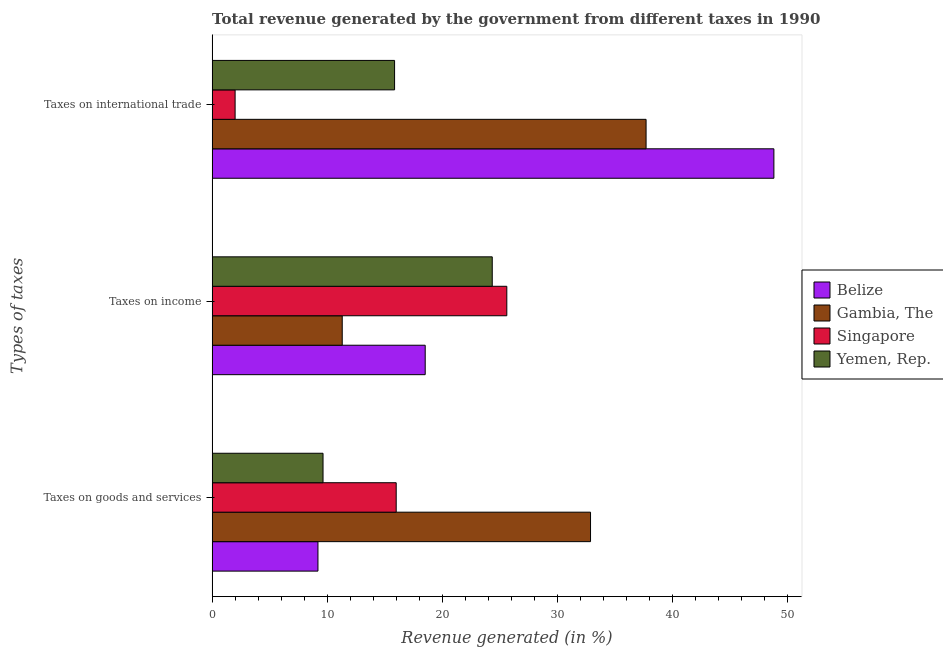How many groups of bars are there?
Provide a succinct answer. 3. Are the number of bars on each tick of the Y-axis equal?
Keep it short and to the point. Yes. What is the label of the 3rd group of bars from the top?
Your response must be concise. Taxes on goods and services. What is the percentage of revenue generated by taxes on income in Singapore?
Make the answer very short. 25.61. Across all countries, what is the maximum percentage of revenue generated by taxes on goods and services?
Your answer should be compact. 32.89. Across all countries, what is the minimum percentage of revenue generated by taxes on income?
Give a very brief answer. 11.31. In which country was the percentage of revenue generated by tax on international trade maximum?
Make the answer very short. Belize. In which country was the percentage of revenue generated by tax on international trade minimum?
Give a very brief answer. Singapore. What is the total percentage of revenue generated by tax on international trade in the graph?
Your answer should be compact. 104.39. What is the difference between the percentage of revenue generated by tax on international trade in Yemen, Rep. and that in Belize?
Keep it short and to the point. -32.97. What is the difference between the percentage of revenue generated by tax on international trade in Singapore and the percentage of revenue generated by taxes on income in Gambia, The?
Provide a short and direct response. -9.31. What is the average percentage of revenue generated by taxes on goods and services per country?
Offer a terse response. 16.93. What is the difference between the percentage of revenue generated by tax on international trade and percentage of revenue generated by taxes on goods and services in Yemen, Rep.?
Make the answer very short. 6.22. In how many countries, is the percentage of revenue generated by tax on international trade greater than 48 %?
Your response must be concise. 1. What is the ratio of the percentage of revenue generated by tax on international trade in Singapore to that in Gambia, The?
Provide a succinct answer. 0.05. Is the percentage of revenue generated by tax on international trade in Yemen, Rep. less than that in Belize?
Keep it short and to the point. Yes. What is the difference between the highest and the second highest percentage of revenue generated by taxes on income?
Make the answer very short. 1.26. What is the difference between the highest and the lowest percentage of revenue generated by taxes on income?
Keep it short and to the point. 14.3. In how many countries, is the percentage of revenue generated by tax on international trade greater than the average percentage of revenue generated by tax on international trade taken over all countries?
Provide a short and direct response. 2. What does the 2nd bar from the top in Taxes on income represents?
Make the answer very short. Singapore. What does the 2nd bar from the bottom in Taxes on goods and services represents?
Make the answer very short. Gambia, The. Is it the case that in every country, the sum of the percentage of revenue generated by taxes on goods and services and percentage of revenue generated by taxes on income is greater than the percentage of revenue generated by tax on international trade?
Ensure brevity in your answer.  No. Are all the bars in the graph horizontal?
Make the answer very short. Yes. What is the difference between two consecutive major ticks on the X-axis?
Offer a terse response. 10. Are the values on the major ticks of X-axis written in scientific E-notation?
Offer a terse response. No. Does the graph contain grids?
Make the answer very short. No. How many legend labels are there?
Offer a terse response. 4. What is the title of the graph?
Make the answer very short. Total revenue generated by the government from different taxes in 1990. Does "Benin" appear as one of the legend labels in the graph?
Keep it short and to the point. No. What is the label or title of the X-axis?
Give a very brief answer. Revenue generated (in %). What is the label or title of the Y-axis?
Provide a short and direct response. Types of taxes. What is the Revenue generated (in %) in Belize in Taxes on goods and services?
Ensure brevity in your answer.  9.2. What is the Revenue generated (in %) of Gambia, The in Taxes on goods and services?
Provide a succinct answer. 32.89. What is the Revenue generated (in %) in Singapore in Taxes on goods and services?
Keep it short and to the point. 16. What is the Revenue generated (in %) in Yemen, Rep. in Taxes on goods and services?
Your response must be concise. 9.64. What is the Revenue generated (in %) of Belize in Taxes on income?
Offer a terse response. 18.52. What is the Revenue generated (in %) in Gambia, The in Taxes on income?
Offer a terse response. 11.31. What is the Revenue generated (in %) in Singapore in Taxes on income?
Your answer should be compact. 25.61. What is the Revenue generated (in %) in Yemen, Rep. in Taxes on income?
Provide a succinct answer. 24.34. What is the Revenue generated (in %) of Belize in Taxes on international trade?
Provide a succinct answer. 48.82. What is the Revenue generated (in %) in Gambia, The in Taxes on international trade?
Offer a very short reply. 37.71. What is the Revenue generated (in %) in Singapore in Taxes on international trade?
Your response must be concise. 2. What is the Revenue generated (in %) in Yemen, Rep. in Taxes on international trade?
Provide a short and direct response. 15.86. Across all Types of taxes, what is the maximum Revenue generated (in %) in Belize?
Keep it short and to the point. 48.82. Across all Types of taxes, what is the maximum Revenue generated (in %) of Gambia, The?
Keep it short and to the point. 37.71. Across all Types of taxes, what is the maximum Revenue generated (in %) in Singapore?
Provide a succinct answer. 25.61. Across all Types of taxes, what is the maximum Revenue generated (in %) of Yemen, Rep.?
Give a very brief answer. 24.34. Across all Types of taxes, what is the minimum Revenue generated (in %) of Belize?
Offer a terse response. 9.2. Across all Types of taxes, what is the minimum Revenue generated (in %) of Gambia, The?
Keep it short and to the point. 11.31. Across all Types of taxes, what is the minimum Revenue generated (in %) of Singapore?
Give a very brief answer. 2. Across all Types of taxes, what is the minimum Revenue generated (in %) of Yemen, Rep.?
Make the answer very short. 9.64. What is the total Revenue generated (in %) of Belize in the graph?
Give a very brief answer. 76.54. What is the total Revenue generated (in %) of Gambia, The in the graph?
Your response must be concise. 81.91. What is the total Revenue generated (in %) in Singapore in the graph?
Keep it short and to the point. 43.6. What is the total Revenue generated (in %) in Yemen, Rep. in the graph?
Ensure brevity in your answer.  49.84. What is the difference between the Revenue generated (in %) in Belize in Taxes on goods and services and that in Taxes on income?
Your answer should be compact. -9.32. What is the difference between the Revenue generated (in %) in Gambia, The in Taxes on goods and services and that in Taxes on income?
Offer a very short reply. 21.58. What is the difference between the Revenue generated (in %) in Singapore in Taxes on goods and services and that in Taxes on income?
Provide a short and direct response. -9.61. What is the difference between the Revenue generated (in %) of Yemen, Rep. in Taxes on goods and services and that in Taxes on income?
Ensure brevity in your answer.  -14.71. What is the difference between the Revenue generated (in %) of Belize in Taxes on goods and services and that in Taxes on international trade?
Your answer should be compact. -39.62. What is the difference between the Revenue generated (in %) of Gambia, The in Taxes on goods and services and that in Taxes on international trade?
Offer a very short reply. -4.83. What is the difference between the Revenue generated (in %) of Singapore in Taxes on goods and services and that in Taxes on international trade?
Keep it short and to the point. 14. What is the difference between the Revenue generated (in %) in Yemen, Rep. in Taxes on goods and services and that in Taxes on international trade?
Give a very brief answer. -6.22. What is the difference between the Revenue generated (in %) of Belize in Taxes on income and that in Taxes on international trade?
Make the answer very short. -30.3. What is the difference between the Revenue generated (in %) of Gambia, The in Taxes on income and that in Taxes on international trade?
Your response must be concise. -26.41. What is the difference between the Revenue generated (in %) in Singapore in Taxes on income and that in Taxes on international trade?
Provide a succinct answer. 23.61. What is the difference between the Revenue generated (in %) in Yemen, Rep. in Taxes on income and that in Taxes on international trade?
Your response must be concise. 8.49. What is the difference between the Revenue generated (in %) in Belize in Taxes on goods and services and the Revenue generated (in %) in Gambia, The in Taxes on income?
Provide a short and direct response. -2.11. What is the difference between the Revenue generated (in %) in Belize in Taxes on goods and services and the Revenue generated (in %) in Singapore in Taxes on income?
Ensure brevity in your answer.  -16.41. What is the difference between the Revenue generated (in %) in Belize in Taxes on goods and services and the Revenue generated (in %) in Yemen, Rep. in Taxes on income?
Ensure brevity in your answer.  -15.15. What is the difference between the Revenue generated (in %) of Gambia, The in Taxes on goods and services and the Revenue generated (in %) of Singapore in Taxes on income?
Provide a short and direct response. 7.28. What is the difference between the Revenue generated (in %) in Gambia, The in Taxes on goods and services and the Revenue generated (in %) in Yemen, Rep. in Taxes on income?
Provide a short and direct response. 8.54. What is the difference between the Revenue generated (in %) in Singapore in Taxes on goods and services and the Revenue generated (in %) in Yemen, Rep. in Taxes on income?
Your answer should be compact. -8.35. What is the difference between the Revenue generated (in %) in Belize in Taxes on goods and services and the Revenue generated (in %) in Gambia, The in Taxes on international trade?
Keep it short and to the point. -28.52. What is the difference between the Revenue generated (in %) in Belize in Taxes on goods and services and the Revenue generated (in %) in Singapore in Taxes on international trade?
Offer a terse response. 7.2. What is the difference between the Revenue generated (in %) of Belize in Taxes on goods and services and the Revenue generated (in %) of Yemen, Rep. in Taxes on international trade?
Keep it short and to the point. -6.66. What is the difference between the Revenue generated (in %) in Gambia, The in Taxes on goods and services and the Revenue generated (in %) in Singapore in Taxes on international trade?
Offer a terse response. 30.89. What is the difference between the Revenue generated (in %) of Gambia, The in Taxes on goods and services and the Revenue generated (in %) of Yemen, Rep. in Taxes on international trade?
Your answer should be compact. 17.03. What is the difference between the Revenue generated (in %) in Singapore in Taxes on goods and services and the Revenue generated (in %) in Yemen, Rep. in Taxes on international trade?
Provide a succinct answer. 0.14. What is the difference between the Revenue generated (in %) of Belize in Taxes on income and the Revenue generated (in %) of Gambia, The in Taxes on international trade?
Give a very brief answer. -19.2. What is the difference between the Revenue generated (in %) in Belize in Taxes on income and the Revenue generated (in %) in Singapore in Taxes on international trade?
Provide a succinct answer. 16.52. What is the difference between the Revenue generated (in %) in Belize in Taxes on income and the Revenue generated (in %) in Yemen, Rep. in Taxes on international trade?
Offer a very short reply. 2.66. What is the difference between the Revenue generated (in %) of Gambia, The in Taxes on income and the Revenue generated (in %) of Singapore in Taxes on international trade?
Make the answer very short. 9.31. What is the difference between the Revenue generated (in %) in Gambia, The in Taxes on income and the Revenue generated (in %) in Yemen, Rep. in Taxes on international trade?
Offer a very short reply. -4.55. What is the difference between the Revenue generated (in %) of Singapore in Taxes on income and the Revenue generated (in %) of Yemen, Rep. in Taxes on international trade?
Provide a succinct answer. 9.75. What is the average Revenue generated (in %) of Belize per Types of taxes?
Your answer should be compact. 25.51. What is the average Revenue generated (in %) of Gambia, The per Types of taxes?
Your response must be concise. 27.3. What is the average Revenue generated (in %) of Singapore per Types of taxes?
Offer a terse response. 14.53. What is the average Revenue generated (in %) in Yemen, Rep. per Types of taxes?
Ensure brevity in your answer.  16.61. What is the difference between the Revenue generated (in %) of Belize and Revenue generated (in %) of Gambia, The in Taxes on goods and services?
Your answer should be very brief. -23.69. What is the difference between the Revenue generated (in %) in Belize and Revenue generated (in %) in Singapore in Taxes on goods and services?
Give a very brief answer. -6.8. What is the difference between the Revenue generated (in %) in Belize and Revenue generated (in %) in Yemen, Rep. in Taxes on goods and services?
Make the answer very short. -0.44. What is the difference between the Revenue generated (in %) of Gambia, The and Revenue generated (in %) of Singapore in Taxes on goods and services?
Ensure brevity in your answer.  16.89. What is the difference between the Revenue generated (in %) of Gambia, The and Revenue generated (in %) of Yemen, Rep. in Taxes on goods and services?
Keep it short and to the point. 23.25. What is the difference between the Revenue generated (in %) of Singapore and Revenue generated (in %) of Yemen, Rep. in Taxes on goods and services?
Provide a succinct answer. 6.36. What is the difference between the Revenue generated (in %) of Belize and Revenue generated (in %) of Gambia, The in Taxes on income?
Make the answer very short. 7.21. What is the difference between the Revenue generated (in %) in Belize and Revenue generated (in %) in Singapore in Taxes on income?
Ensure brevity in your answer.  -7.09. What is the difference between the Revenue generated (in %) in Belize and Revenue generated (in %) in Yemen, Rep. in Taxes on income?
Provide a short and direct response. -5.83. What is the difference between the Revenue generated (in %) of Gambia, The and Revenue generated (in %) of Singapore in Taxes on income?
Offer a very short reply. -14.3. What is the difference between the Revenue generated (in %) in Gambia, The and Revenue generated (in %) in Yemen, Rep. in Taxes on income?
Give a very brief answer. -13.04. What is the difference between the Revenue generated (in %) in Singapore and Revenue generated (in %) in Yemen, Rep. in Taxes on income?
Provide a succinct answer. 1.26. What is the difference between the Revenue generated (in %) in Belize and Revenue generated (in %) in Gambia, The in Taxes on international trade?
Offer a terse response. 11.11. What is the difference between the Revenue generated (in %) in Belize and Revenue generated (in %) in Singapore in Taxes on international trade?
Your answer should be compact. 46.82. What is the difference between the Revenue generated (in %) in Belize and Revenue generated (in %) in Yemen, Rep. in Taxes on international trade?
Offer a very short reply. 32.97. What is the difference between the Revenue generated (in %) of Gambia, The and Revenue generated (in %) of Singapore in Taxes on international trade?
Ensure brevity in your answer.  35.72. What is the difference between the Revenue generated (in %) in Gambia, The and Revenue generated (in %) in Yemen, Rep. in Taxes on international trade?
Offer a terse response. 21.86. What is the difference between the Revenue generated (in %) of Singapore and Revenue generated (in %) of Yemen, Rep. in Taxes on international trade?
Provide a succinct answer. -13.86. What is the ratio of the Revenue generated (in %) in Belize in Taxes on goods and services to that in Taxes on income?
Keep it short and to the point. 0.5. What is the ratio of the Revenue generated (in %) of Gambia, The in Taxes on goods and services to that in Taxes on income?
Your answer should be very brief. 2.91. What is the ratio of the Revenue generated (in %) of Singapore in Taxes on goods and services to that in Taxes on income?
Make the answer very short. 0.62. What is the ratio of the Revenue generated (in %) of Yemen, Rep. in Taxes on goods and services to that in Taxes on income?
Your answer should be compact. 0.4. What is the ratio of the Revenue generated (in %) of Belize in Taxes on goods and services to that in Taxes on international trade?
Provide a succinct answer. 0.19. What is the ratio of the Revenue generated (in %) of Gambia, The in Taxes on goods and services to that in Taxes on international trade?
Provide a short and direct response. 0.87. What is the ratio of the Revenue generated (in %) in Singapore in Taxes on goods and services to that in Taxes on international trade?
Offer a terse response. 8.01. What is the ratio of the Revenue generated (in %) in Yemen, Rep. in Taxes on goods and services to that in Taxes on international trade?
Give a very brief answer. 0.61. What is the ratio of the Revenue generated (in %) of Belize in Taxes on income to that in Taxes on international trade?
Give a very brief answer. 0.38. What is the ratio of the Revenue generated (in %) in Gambia, The in Taxes on income to that in Taxes on international trade?
Offer a very short reply. 0.3. What is the ratio of the Revenue generated (in %) in Singapore in Taxes on income to that in Taxes on international trade?
Offer a very short reply. 12.82. What is the ratio of the Revenue generated (in %) of Yemen, Rep. in Taxes on income to that in Taxes on international trade?
Your response must be concise. 1.54. What is the difference between the highest and the second highest Revenue generated (in %) of Belize?
Keep it short and to the point. 30.3. What is the difference between the highest and the second highest Revenue generated (in %) in Gambia, The?
Ensure brevity in your answer.  4.83. What is the difference between the highest and the second highest Revenue generated (in %) in Singapore?
Provide a short and direct response. 9.61. What is the difference between the highest and the second highest Revenue generated (in %) of Yemen, Rep.?
Offer a terse response. 8.49. What is the difference between the highest and the lowest Revenue generated (in %) in Belize?
Your answer should be very brief. 39.62. What is the difference between the highest and the lowest Revenue generated (in %) in Gambia, The?
Provide a short and direct response. 26.41. What is the difference between the highest and the lowest Revenue generated (in %) of Singapore?
Your response must be concise. 23.61. What is the difference between the highest and the lowest Revenue generated (in %) in Yemen, Rep.?
Make the answer very short. 14.71. 